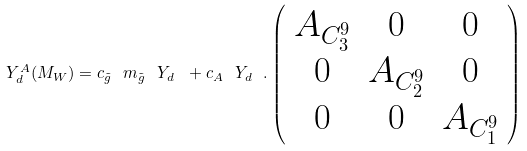<formula> <loc_0><loc_0><loc_500><loc_500>Y _ { d } ^ { A } ( M _ { W } ) = c _ { \tilde { g } } \ m _ { \tilde { g } } \ Y _ { d } \ + c _ { A } \ Y _ { d } \ . \left ( \begin{array} { c c c } { { A _ { C _ { 3 } ^ { 9 } } } } & { 0 } & { 0 } \\ { 0 } & { { A _ { C _ { 2 } ^ { 9 } } } } & { 0 } \\ { 0 } & { 0 } & { { A _ { C _ { 1 } ^ { 9 } } } } \end{array} \right )</formula> 